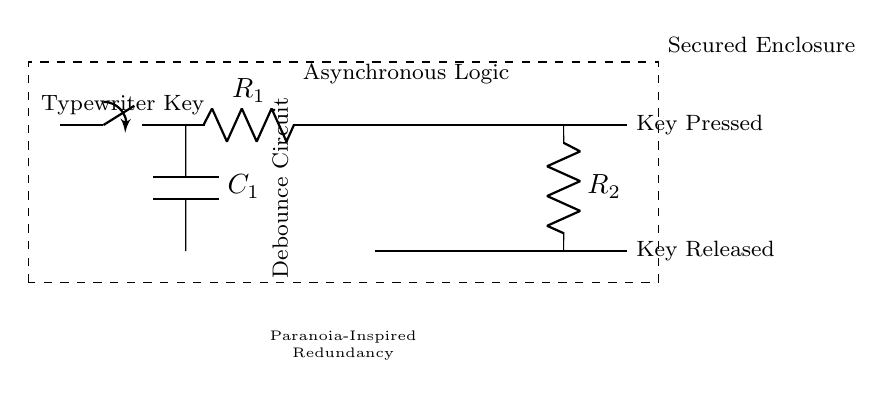What type of switch is used in this circuit? The circuit diagram shows a switch type, specifically a mechanical switch that represents the typewriter key mechanism.
Answer: Switch What component acts as a debouncing mechanism? The capacitor labeled C1 serves as the debouncing mechanism to filter out noise caused by key presses.
Answer: Capacitor How many logic gates are present in the asynchronous logic section? There are two logic gates shown in the circuit: one OR gate and one AND gate.
Answer: Two What is the purpose of resistor R2 in this circuit? Resistor R2 is part of the feedback loop, helping to stabilize the output signal by controlling current flow.
Answer: Stabilization Why is redundancy mentioned in this circuit? Redundancy is shown as a necessity in the circuit design to ensure reliable functioning despite potential failures, reflecting Cold War paranoia.
Answer: Reliability What happens when the key is pressed according to the circuit diagram? When the key is pressed, the output indicates the key has been pressed, activating the corresponding logic gates.
Answer: Key Pressed 